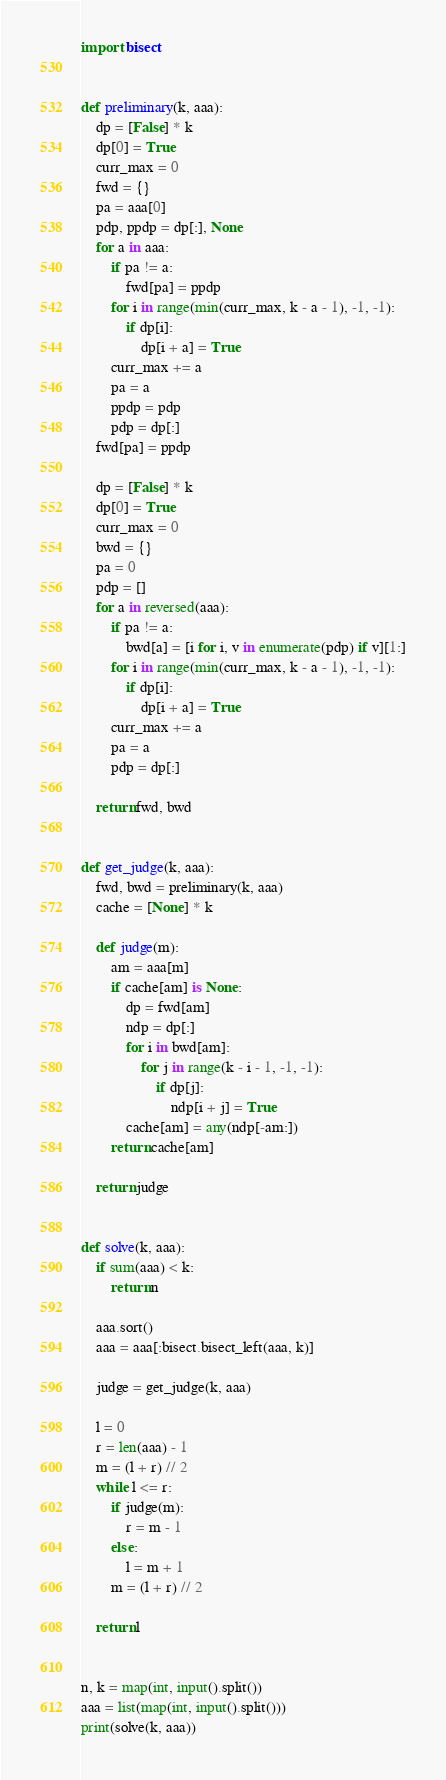<code> <loc_0><loc_0><loc_500><loc_500><_Python_>import bisect


def preliminary(k, aaa):
    dp = [False] * k
    dp[0] = True
    curr_max = 0
    fwd = {}
    pa = aaa[0]
    pdp, ppdp = dp[:], None
    for a in aaa:
        if pa != a:
            fwd[pa] = ppdp
        for i in range(min(curr_max, k - a - 1), -1, -1):
            if dp[i]:
                dp[i + a] = True
        curr_max += a
        pa = a
        ppdp = pdp
        pdp = dp[:]
    fwd[pa] = ppdp

    dp = [False] * k
    dp[0] = True
    curr_max = 0
    bwd = {}
    pa = 0
    pdp = []
    for a in reversed(aaa):
        if pa != a:
            bwd[a] = [i for i, v in enumerate(pdp) if v][1:]
        for i in range(min(curr_max, k - a - 1), -1, -1):
            if dp[i]:
                dp[i + a] = True
        curr_max += a
        pa = a
        pdp = dp[:]

    return fwd, bwd


def get_judge(k, aaa):
    fwd, bwd = preliminary(k, aaa)
    cache = [None] * k

    def judge(m):
        am = aaa[m]
        if cache[am] is None:
            dp = fwd[am]
            ndp = dp[:]
            for i in bwd[am]:
                for j in range(k - i - 1, -1, -1):
                    if dp[j]:
                        ndp[i + j] = True
            cache[am] = any(ndp[-am:])
        return cache[am]

    return judge


def solve(k, aaa):
    if sum(aaa) < k:
        return n

    aaa.sort()
    aaa = aaa[:bisect.bisect_left(aaa, k)]

    judge = get_judge(k, aaa)

    l = 0
    r = len(aaa) - 1
    m = (l + r) // 2
    while l <= r:
        if judge(m):
            r = m - 1
        else:
            l = m + 1
        m = (l + r) // 2

    return l


n, k = map(int, input().split())
aaa = list(map(int, input().split()))
print(solve(k, aaa))
</code> 